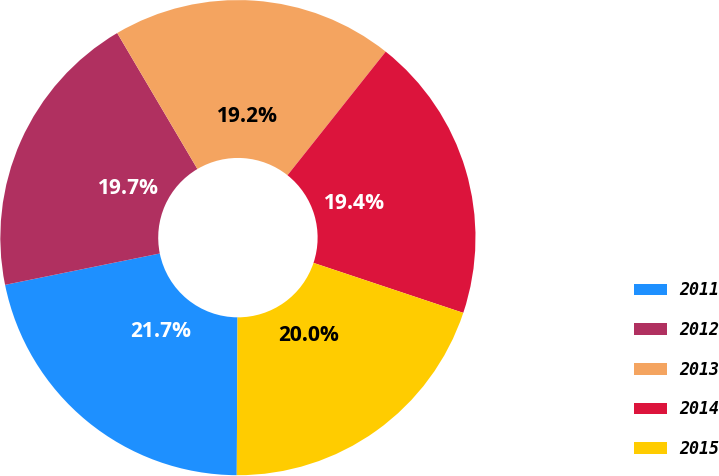<chart> <loc_0><loc_0><loc_500><loc_500><pie_chart><fcel>2011<fcel>2012<fcel>2013<fcel>2014<fcel>2015<nl><fcel>21.74%<fcel>19.7%<fcel>19.17%<fcel>19.44%<fcel>19.95%<nl></chart> 